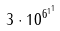<formula> <loc_0><loc_0><loc_500><loc_500>3 \cdot 1 0 ^ { { 6 ^ { 1 } } ^ { 1 } }</formula> 